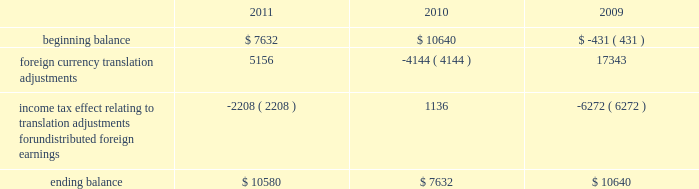The table sets forth the components of foreign currency translation adjustments for fiscal 2011 , 2010 and 2009 ( in thousands ) : beginning balance foreign currency translation adjustments income tax effect relating to translation adjustments for undistributed foreign earnings ending balance $ 7632 ( 2208 ) $ 10580 $ 10640 ( 4144 ) $ 7632 $ ( 431 ) 17343 ( 6272 ) $ 10640 stock repurchase program to facilitate our stock repurchase program , designed to return value to our stockholders and minimize dilution from stock issuances , we repurchase shares in the open market and also enter into structured repurchase agreements with third-parties .
Authorization to repurchase shares to cover on-going dilution was not subject to expiration .
However , this repurchase program was limited to covering net dilution from stock issuances and was subject to business conditions and cash flow requirements as determined by our board of directors from time to time .
During the third quarter of fiscal 2010 , our board of directors approved an amendment to our stock repurchase program authorized in april 2007 from a non-expiring share-based authority to a time-constrained dollar-based authority .
As part of this amendment , the board of directors granted authority to repurchase up to $ 1.6 billion in common stock through the end of fiscal 2012 .
This amended program did not affect the $ 250.0 million structured stock repurchase agreement entered into during march 2010 .
As of december 3 , 2010 , no prepayments remain under that agreement .
During fiscal 2011 , 2010 and 2009 , we entered into several structured repurchase agreements with large financial institutions , whereupon we provided the financial institutions with prepayments totaling $ 695.0 million , $ 850.0 million and $ 350.0 million , respectively .
Of the $ 850.0 million of prepayments during fiscal 2010 , $ 250.0 million was under the stock repurchase program prior to the program amendment and the remaining $ 600.0 million was under the amended $ 1.6 billion time-constrained dollar- based authority .
We enter into these agreements in order to take advantage of repurchasing shares at a guaranteed discount to the volume weighted average price ( 201cvwap 201d ) of our common stock over a specified period of time .
We only enter into such transactions when the discount that we receive is higher than the foregone return on our cash prepayments to the financial institutions .
There were no explicit commissions or fees on these structured repurchases .
Under the terms of the agreements , there is no requirement for the financial institutions to return any portion of the prepayment to us .
The financial institutions agree to deliver shares to us at monthly intervals during the contract term .
The parameters used to calculate the number of shares deliverable are : the total notional amount of the contract , the number of trading days in the contract , the number of trading days in the interval and the average vwap of our stock during the interval less the agreed upon discount .
During fiscal 2011 , we repurchased approximately 21.8 million shares at an average price of $ 31.81 through structured repurchase agreements entered into during fiscal 2011 .
During fiscal 2010 , we repurchased approximately 31.2 million shares at an average price of $ 29.19 through structured repurchase agreements entered into during fiscal 2009 and fiscal 2010 .
During fiscal 2009 , we repurchased approximately 15.2 million shares at an average price per share of $ 27.89 through structured repurchase agreements entered into during fiscal 2008 and fiscal 2009 .
For fiscal 2011 , 2010 and 2009 , the prepayments were classified as treasury stock on our consolidated balance sheets at the payment date , though only shares physically delivered to us by december 2 , 2011 , december 3 , 2010 and november 27 , 2009 were excluded from the computation of earnings per share .
As of december 2 , 2011 and december 3 , 2010 , no prepayments remained under these agreements .
As of november 27 , 2009 , approximately $ 59.9 million of prepayments remained under these agreements .
Subsequent to december 2 , 2011 , as part of our $ 1.6 billion stock repurchase program , we entered into a structured stock repurchase agreement with a large financial institution whereupon we provided them with a prepayment of $ 80.0 million .
This amount will be classified as treasury stock on our consolidated balance sheets .
Upon completion of the $ 80.0 million stock table of contents adobe systems incorporated notes to consolidated financial statements ( continued ) jarcamo typewritten text .
The following table sets forth the components of foreign currency translation adjustments for fiscal 2011 , 2010 and 2009 ( in thousands ) : beginning balance foreign currency translation adjustments income tax effect relating to translation adjustments for undistributed foreign earnings ending balance $ 7632 ( 2208 ) $ 10580 $ 10640 ( 4144 ) $ 7632 $ ( 431 ) 17343 ( 6272 ) $ 10640 stock repurchase program to facilitate our stock repurchase program , designed to return value to our stockholders and minimize dilution from stock issuances , we repurchase shares in the open market and also enter into structured repurchase agreements with third-parties .
Authorization to repurchase shares to cover on-going dilution was not subject to expiration .
However , this repurchase program was limited to covering net dilution from stock issuances and was subject to business conditions and cash flow requirements as determined by our board of directors from time to time .
During the third quarter of fiscal 2010 , our board of directors approved an amendment to our stock repurchase program authorized in april 2007 from a non-expiring share-based authority to a time-constrained dollar-based authority .
As part of this amendment , the board of directors granted authority to repurchase up to $ 1.6 billion in common stock through the end of fiscal 2012 .
This amended program did not affect the $ 250.0 million structured stock repurchase agreement entered into during march 2010 .
As of december 3 , 2010 , no prepayments remain under that agreement .
During fiscal 2011 , 2010 and 2009 , we entered into several structured repurchase agreements with large financial institutions , whereupon we provided the financial institutions with prepayments totaling $ 695.0 million , $ 850.0 million and $ 350.0 million , respectively .
Of the $ 850.0 million of prepayments during fiscal 2010 , $ 250.0 million was under the stock repurchase program prior to the program amendment and the remaining $ 600.0 million was under the amended $ 1.6 billion time-constrained dollar- based authority .
We enter into these agreements in order to take advantage of repurchasing shares at a guaranteed discount to the volume weighted average price ( 201cvwap 201d ) of our common stock over a specified period of time .
We only enter into such transactions when the discount that we receive is higher than the foregone return on our cash prepayments to the financial institutions .
There were no explicit commissions or fees on these structured repurchases .
Under the terms of the agreements , there is no requirement for the financial institutions to return any portion of the prepayment to us .
The financial institutions agree to deliver shares to us at monthly intervals during the contract term .
The parameters used to calculate the number of shares deliverable are : the total notional amount of the contract , the number of trading days in the contract , the number of trading days in the interval and the average vwap of our stock during the interval less the agreed upon discount .
During fiscal 2011 , we repurchased approximately 21.8 million shares at an average price of $ 31.81 through structured repurchase agreements entered into during fiscal 2011 .
During fiscal 2010 , we repurchased approximately 31.2 million shares at an average price of $ 29.19 through structured repurchase agreements entered into during fiscal 2009 and fiscal 2010 .
During fiscal 2009 , we repurchased approximately 15.2 million shares at an average price per share of $ 27.89 through structured repurchase agreements entered into during fiscal 2008 and fiscal 2009 .
For fiscal 2011 , 2010 and 2009 , the prepayments were classified as treasury stock on our consolidated balance sheets at the payment date , though only shares physically delivered to us by december 2 , 2011 , december 3 , 2010 and november 27 , 2009 were excluded from the computation of earnings per share .
As of december 2 , 2011 and december 3 , 2010 , no prepayments remained under these agreements .
As of november 27 , 2009 , approximately $ 59.9 million of prepayments remained under these agreements .
Subsequent to december 2 , 2011 , as part of our $ 1.6 billion stock repurchase program , we entered into a structured stock repurchase agreement with a large financial institution whereupon we provided them with a prepayment of $ 80.0 million .
This amount will be classified as treasury stock on our consolidated balance sheets .
Upon completion of the $ 80.0 million stock table of contents adobe systems incorporated notes to consolidated financial statements ( continued ) jarcamo typewritten text .
What is the growth rate in the average price of repurchased shares from 2010 to 2011? 
Computations: ((31.81 - 29.19) / 29.19)
Answer: 0.08976. 